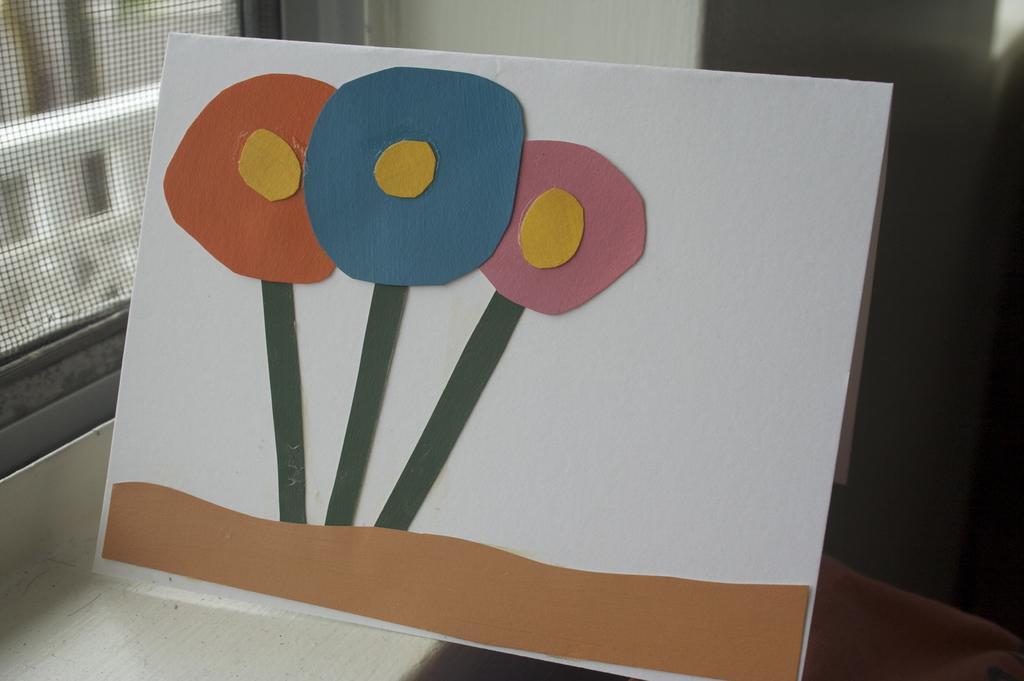Can you describe this image briefly? In this picture there is a painting on a white sheet and there is a net in the left corner. 